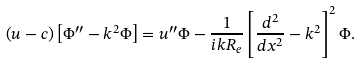Convert formula to latex. <formula><loc_0><loc_0><loc_500><loc_500>\left ( u - c \right ) \left [ \Phi ^ { \prime \prime } - k ^ { 2 } \Phi \right ] = u ^ { \prime \prime } \Phi - \frac { 1 } { i k R _ { e } } \left [ \frac { d ^ { 2 } } { d x ^ { 2 } } - k ^ { 2 } \right ] ^ { 2 } \Phi .</formula> 